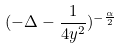Convert formula to latex. <formula><loc_0><loc_0><loc_500><loc_500>( - \Delta - \frac { 1 } { 4 y ^ { 2 } } ) ^ { - \frac { \alpha } { 2 } }</formula> 